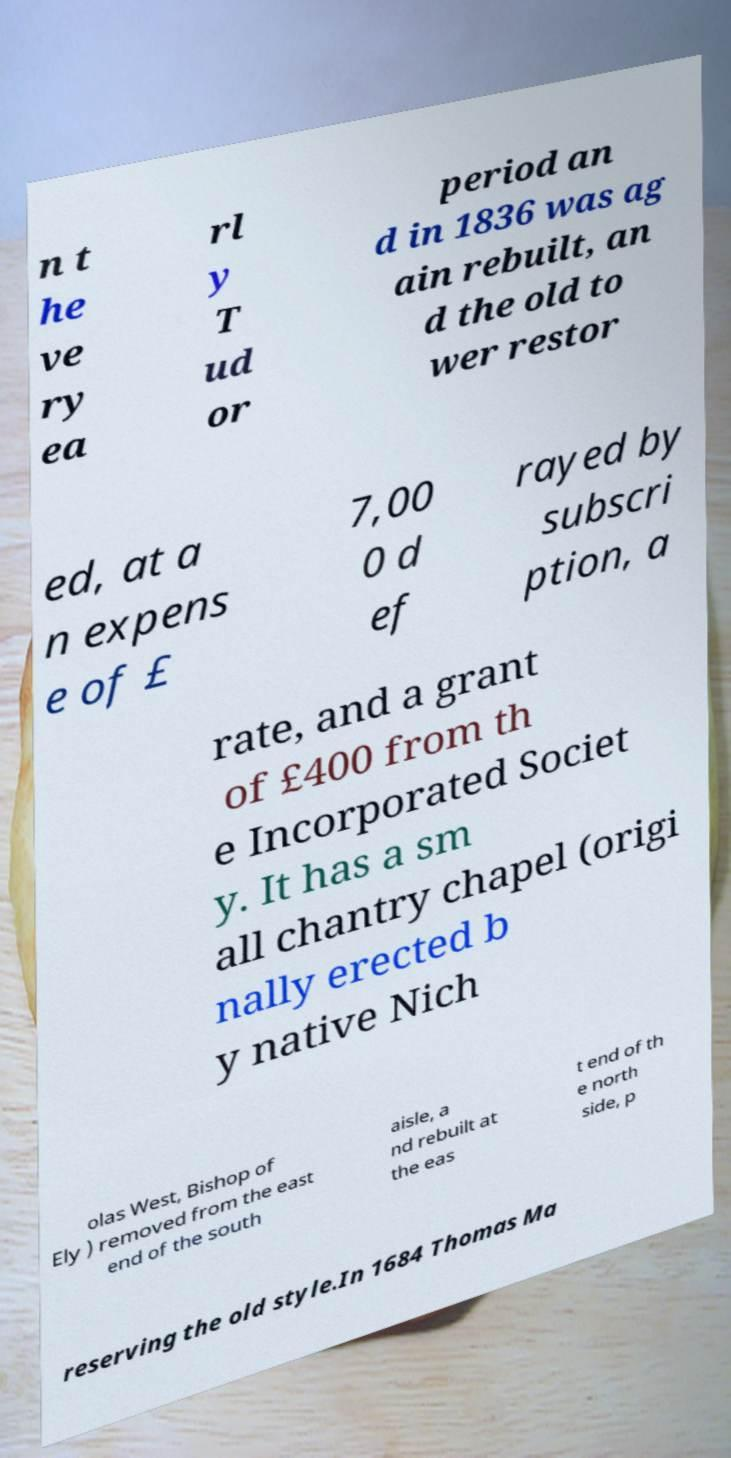I need the written content from this picture converted into text. Can you do that? n t he ve ry ea rl y T ud or period an d in 1836 was ag ain rebuilt, an d the old to wer restor ed, at a n expens e of £ 7,00 0 d ef rayed by subscri ption, a rate, and a grant of £400 from th e Incorporated Societ y. It has a sm all chantry chapel (origi nally erected b y native Nich olas West, Bishop of Ely ) removed from the east end of the south aisle, a nd rebuilt at the eas t end of th e north side, p reserving the old style.In 1684 Thomas Ma 